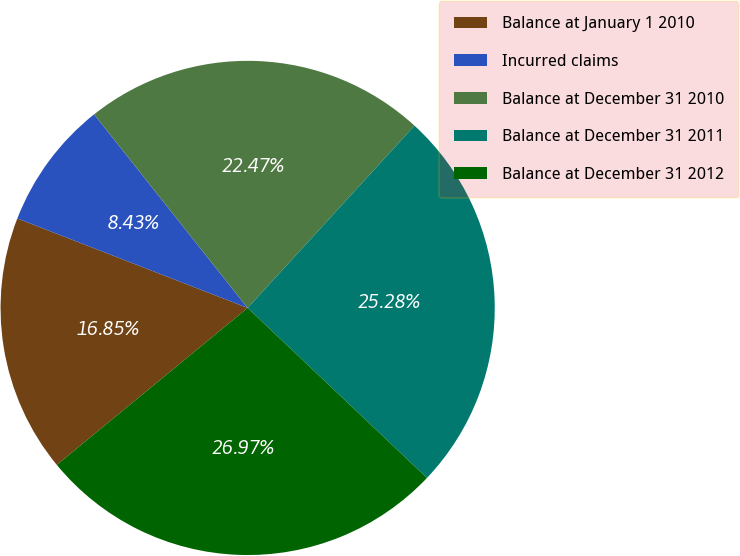Convert chart to OTSL. <chart><loc_0><loc_0><loc_500><loc_500><pie_chart><fcel>Balance at January 1 2010<fcel>Incurred claims<fcel>Balance at December 31 2010<fcel>Balance at December 31 2011<fcel>Balance at December 31 2012<nl><fcel>16.85%<fcel>8.43%<fcel>22.47%<fcel>25.28%<fcel>26.97%<nl></chart> 